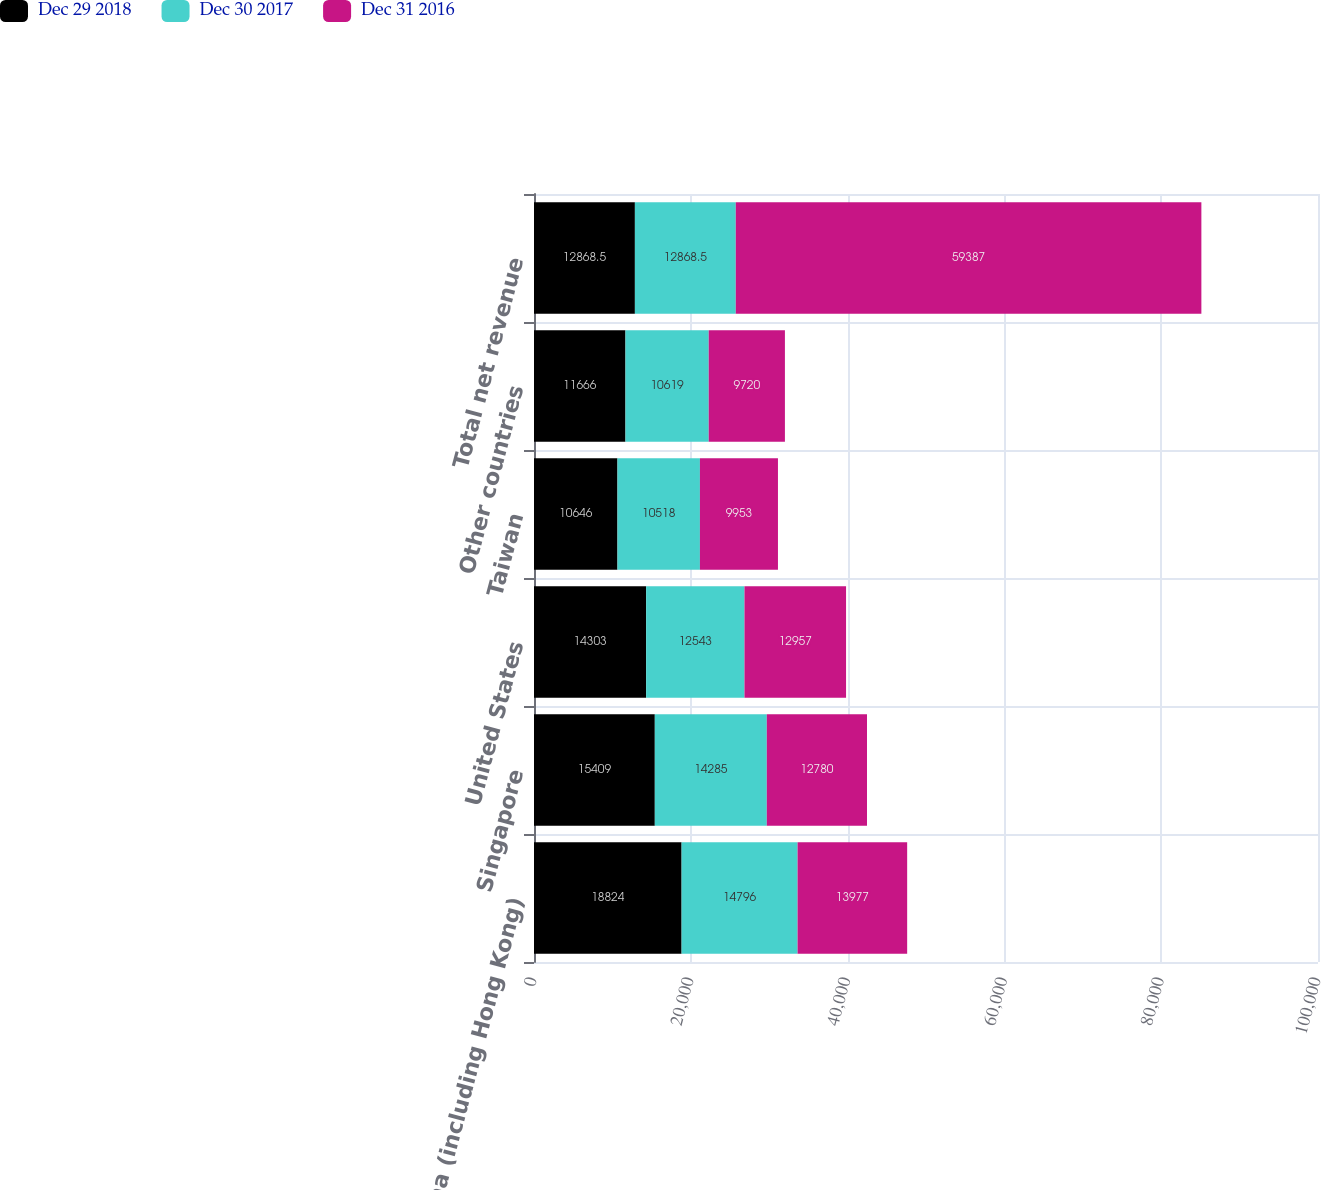Convert chart to OTSL. <chart><loc_0><loc_0><loc_500><loc_500><stacked_bar_chart><ecel><fcel>China (including Hong Kong)<fcel>Singapore<fcel>United States<fcel>Taiwan<fcel>Other countries<fcel>Total net revenue<nl><fcel>Dec 29 2018<fcel>18824<fcel>15409<fcel>14303<fcel>10646<fcel>11666<fcel>12868.5<nl><fcel>Dec 30 2017<fcel>14796<fcel>14285<fcel>12543<fcel>10518<fcel>10619<fcel>12868.5<nl><fcel>Dec 31 2016<fcel>13977<fcel>12780<fcel>12957<fcel>9953<fcel>9720<fcel>59387<nl></chart> 